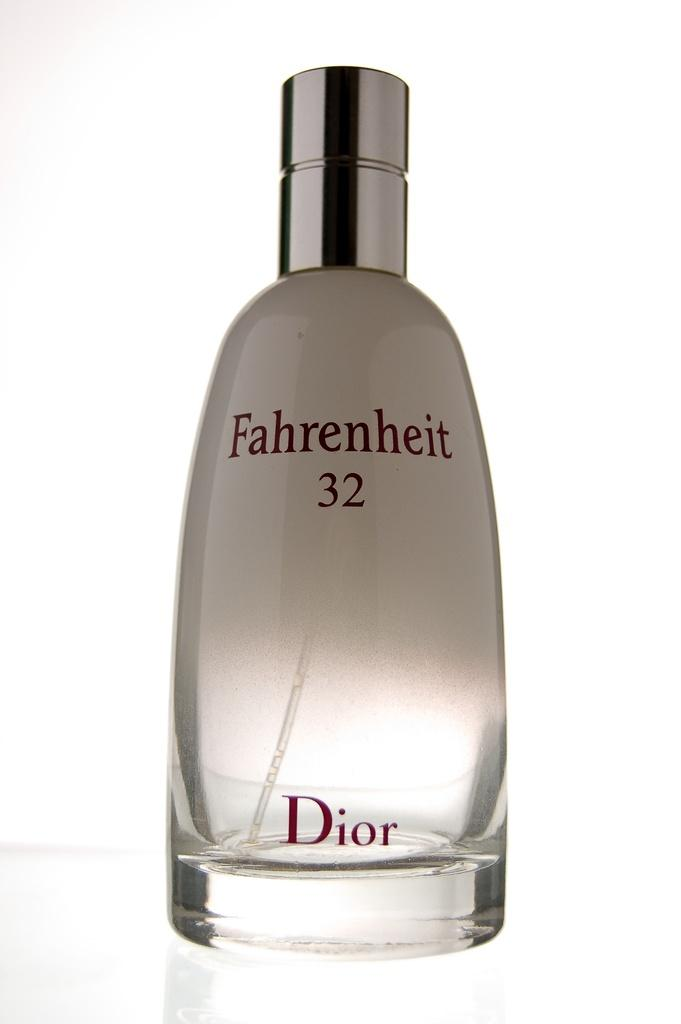<image>
Offer a succinct explanation of the picture presented. A backlit bottle of Farenheit 32 by Dior. 